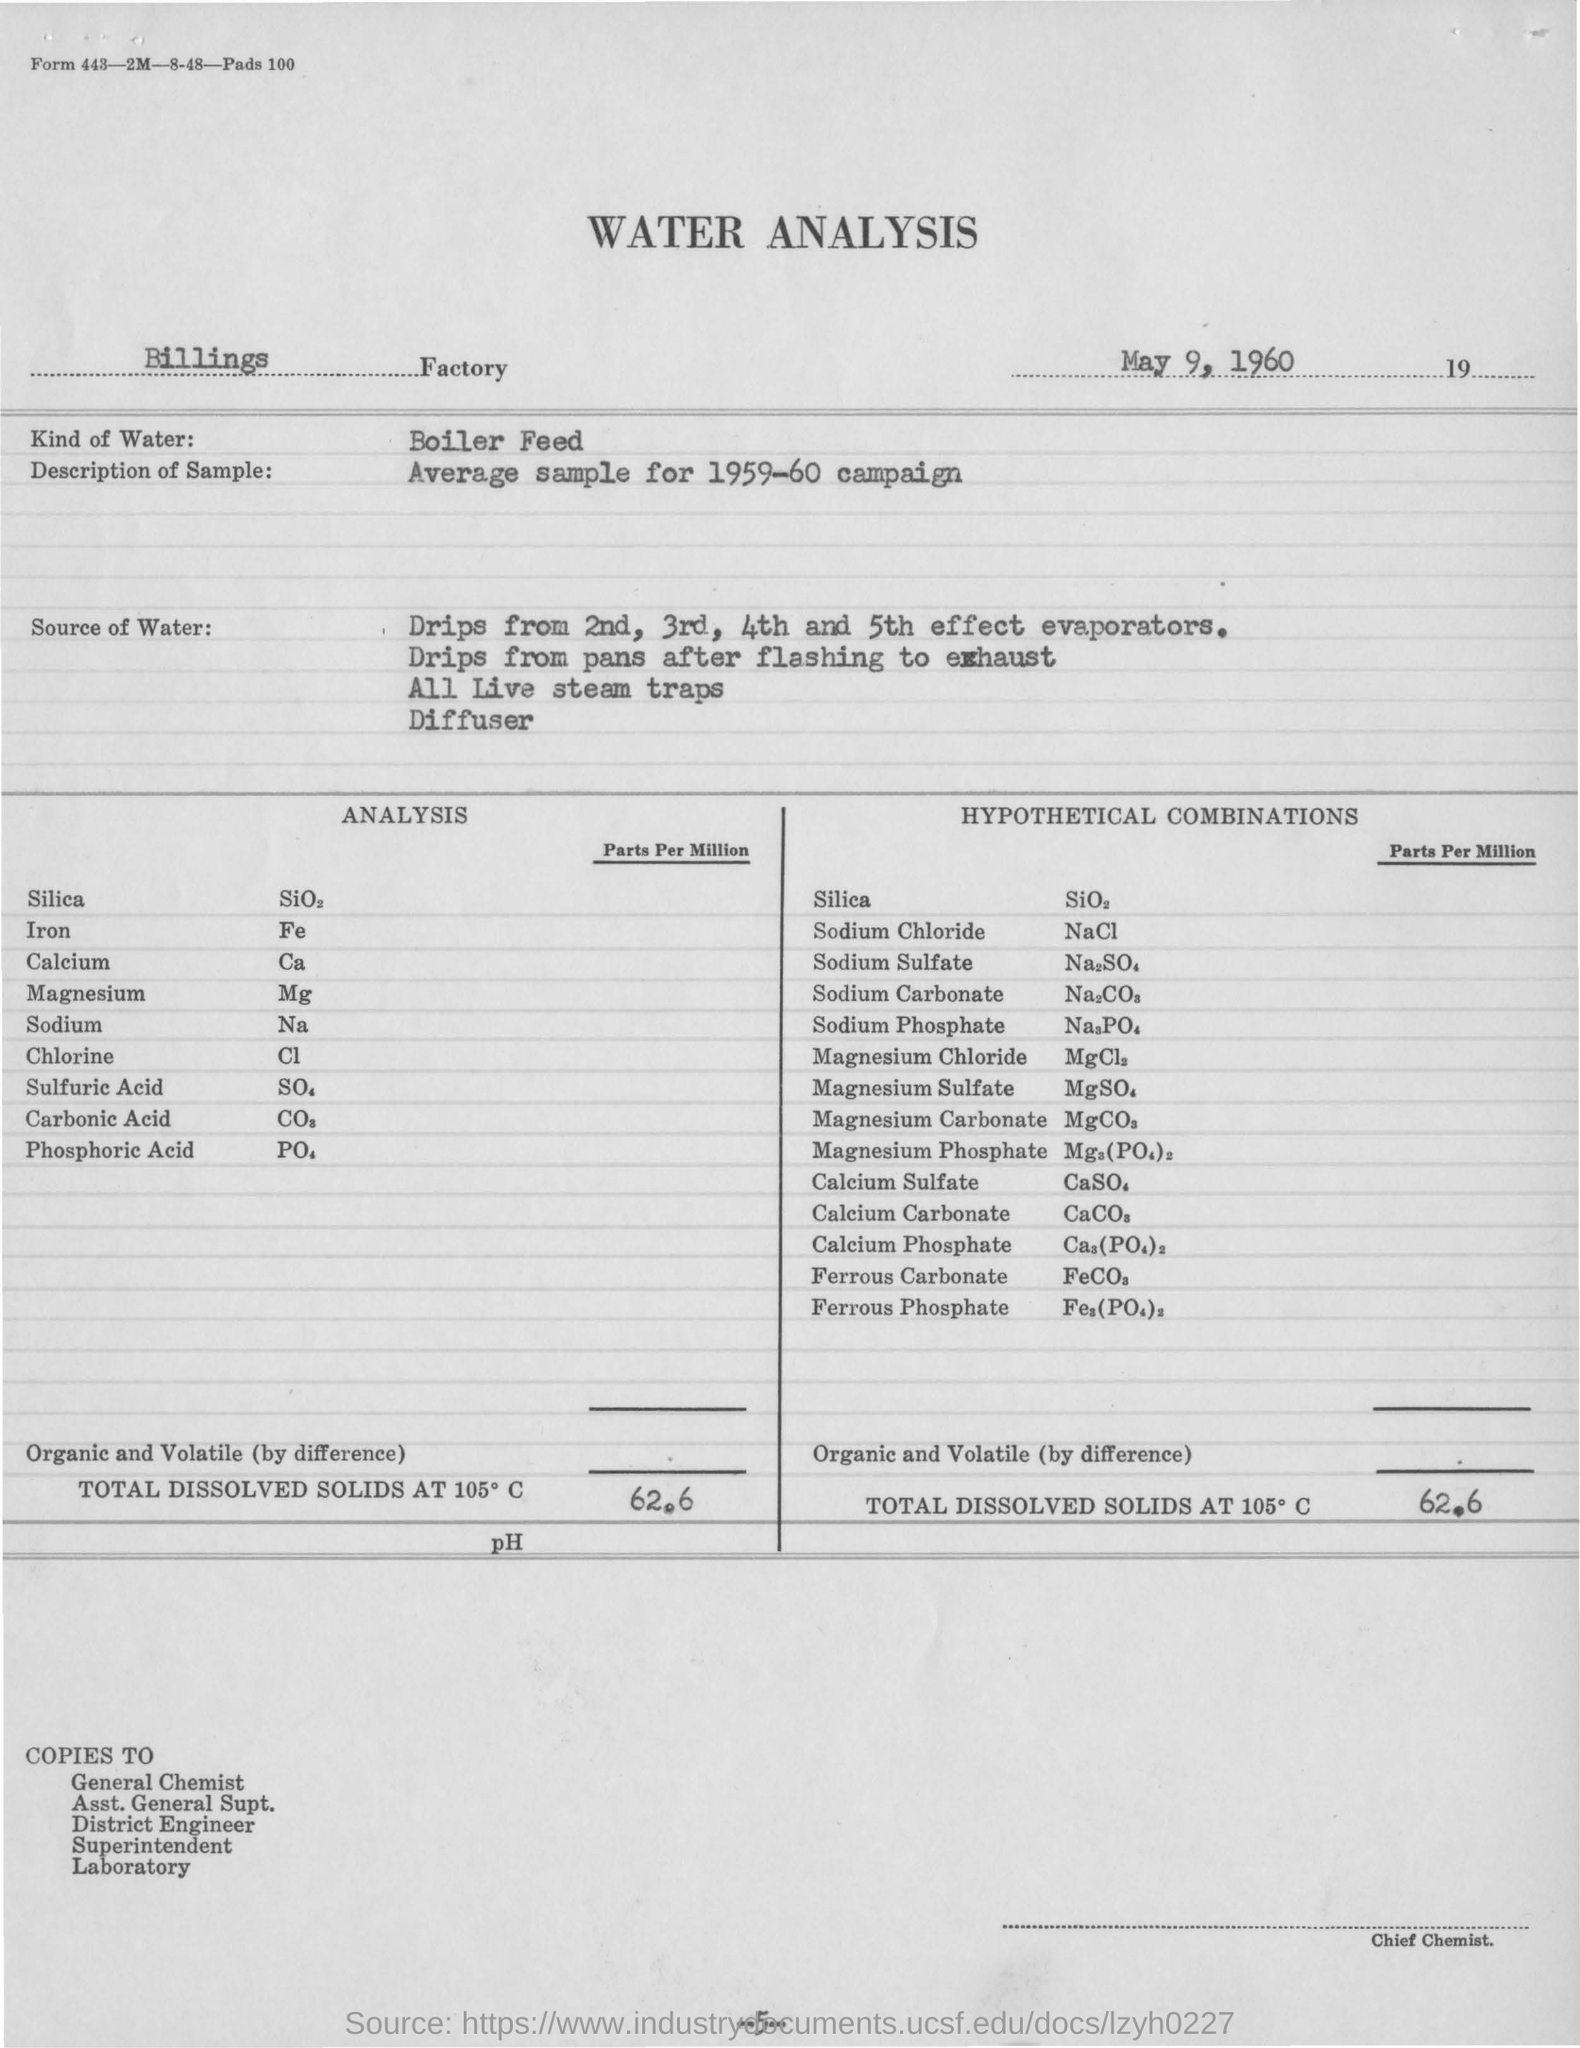Give some essential details in this illustration. The analysis used boiler feed water as the source of water for the analysis. The date mentioned in the report is May 9, 1960. 